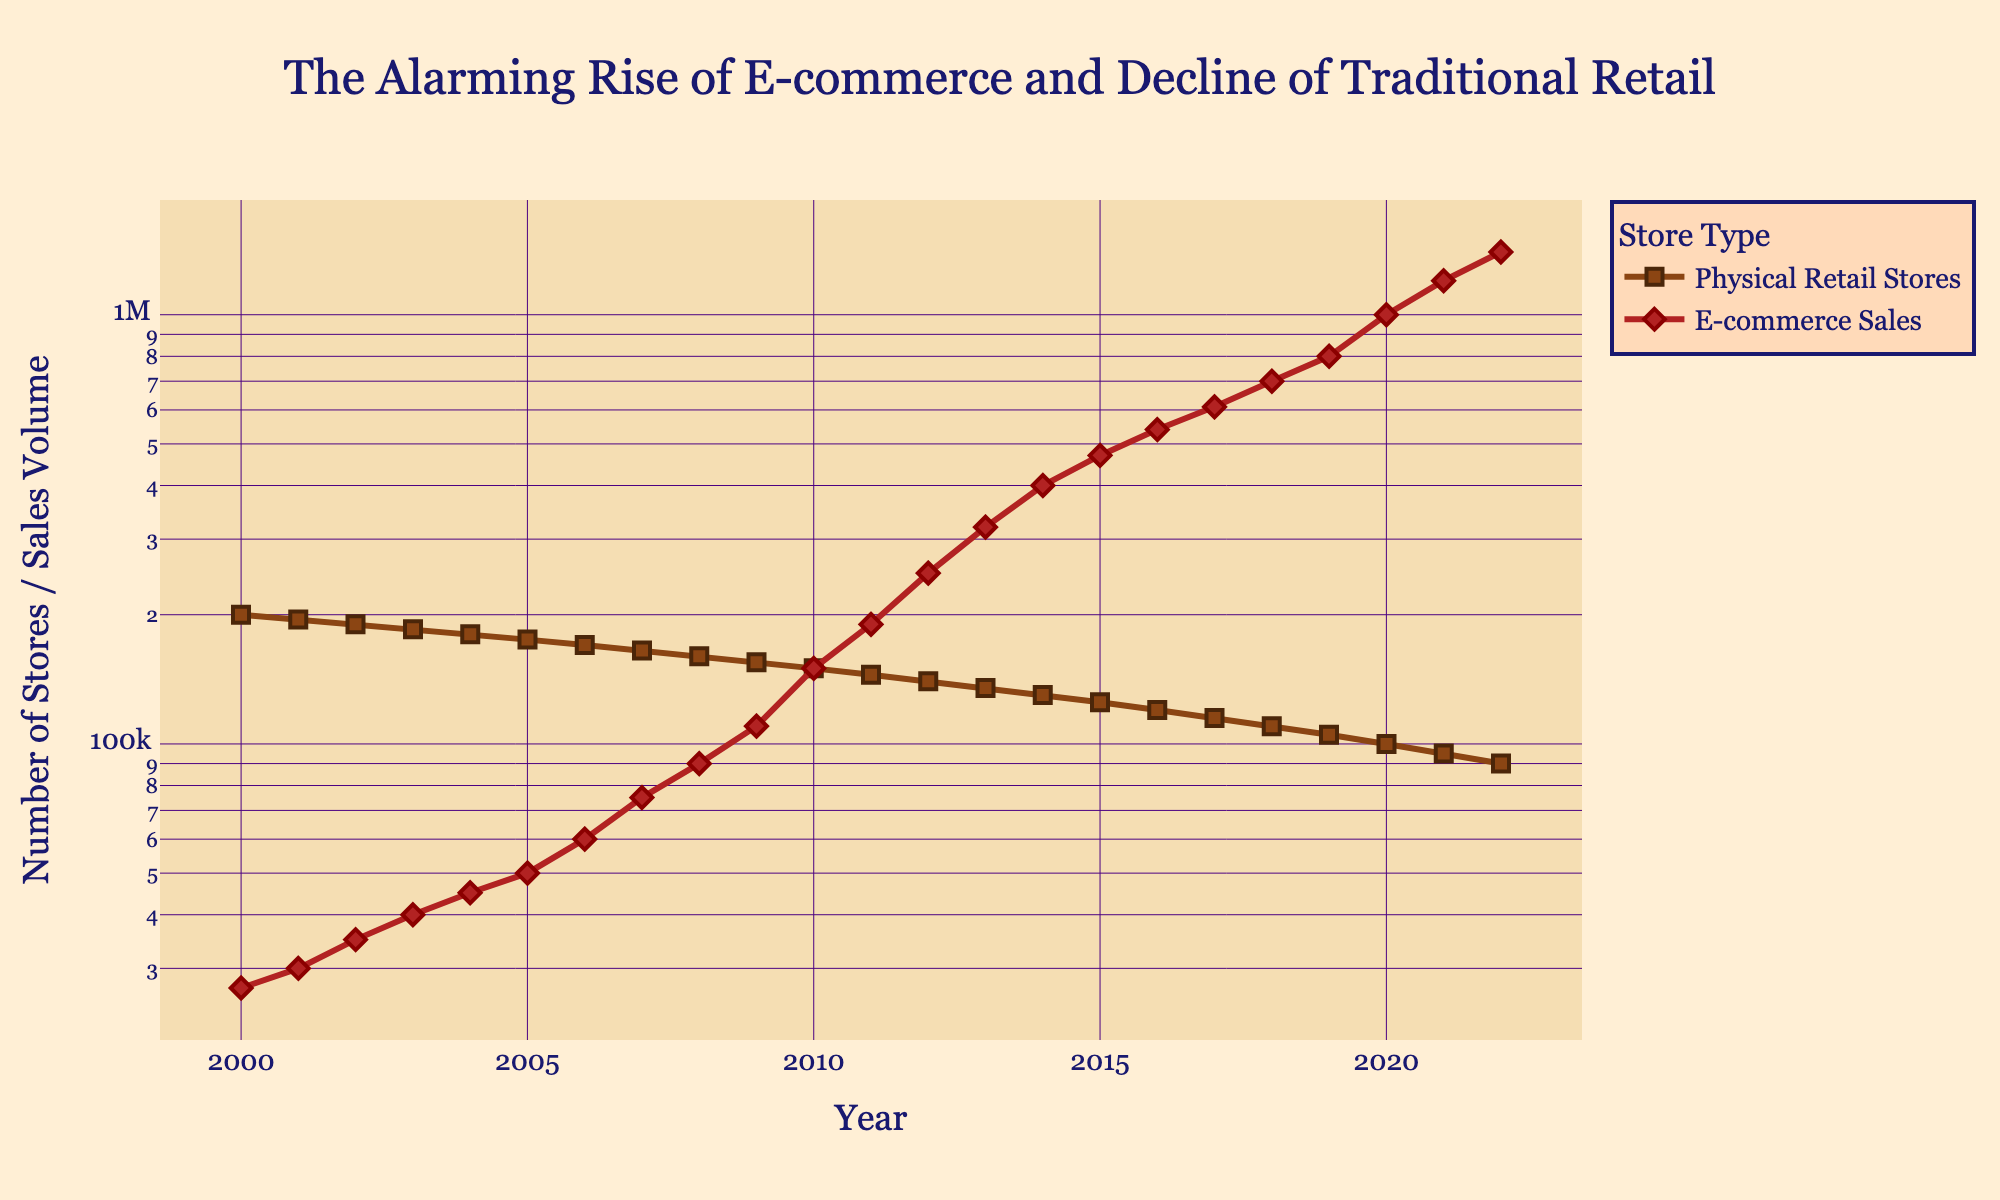What is the title of the figure? The title is located at the top of the figure and is typically the largest and most prominent text. It reads "The Alarming Rise of E-commerce and Decline of Traditional Retail".
Answer: The Alarming Rise of E-commerce and Decline of Traditional Retail Which line represents Physical Retail Stores? In the legend, the line for Physical Retail Stores is indicated. It is colored in brown ('#8B4513') and uses square markers.
Answer: Brown line with square markers How many data points are shown for each line? Each line has a marker for each year from 2000 to 2022. Counting these markers gives the total number of data points for each line.
Answer: 23 What was the number of Physical Retail Stores in 2005? Locate the point on the brown line (Physical Retail Stores) corresponding to the year 2005 on the x-axis. The y-coordinate of this point represents the number of stores.
Answer: 175,000 What is the trend for E-commerce Sales over the years? Observe the red line (E-commerce Sales) trend from left to right. The line shows an upward trend, which indicates that E-commerce Sales have been increasing over the years.
Answer: Increasing By how much did E-commerce Sales rise from 2015 to 2016? Identify the y-values of the red line (E-commerce Sales) in 2015 and 2016. Subtract the 2015 value from the 2016 value to find the increase.
Answer: 70,000 How do the trajectories of Physical Retail Stores and E-commerce Sales differ from 2000 to 2022? Compare the shapes and slopes of the brown line (Physical Retail Stores) and the red line (E-commerce Sales) over the time period. The brown line has a downward trend, while the red line has an upward trend, indicating an inverse relationship.
Answer: Downward trend vs. Upward trend In what year does E-commerce Sales surpass the number of Physical Retail Stores? Find the intersection point of the red line (E-commerce Sales) and the brown line (Physical Retail Stores). This occurs when the red line's y-value first becomes higher than the brown line's y-value.
Answer: 2010 Which line has a steeper slope from 2010 to 2022? Compare the steepness of the slopes for the red line (E-commerce Sales) and the brown line (Physical Retail Stores) from 2010 to 2022. The steeper slope indicates a faster rate of change.
Answer: E-commerce Sales line What does the log scale on the y-axis indicate about the growth rates of E-commerce Sales and Physical Retail Stores? A log scale helps to visualize exponential growth, showing that E-commerce Sales have been growing exponentially, whereas Physical Retail Stores have been declining more linearly.
Answer: E-commerce Sales are growing exponentially, Physical Retail Stores are declining linearly 